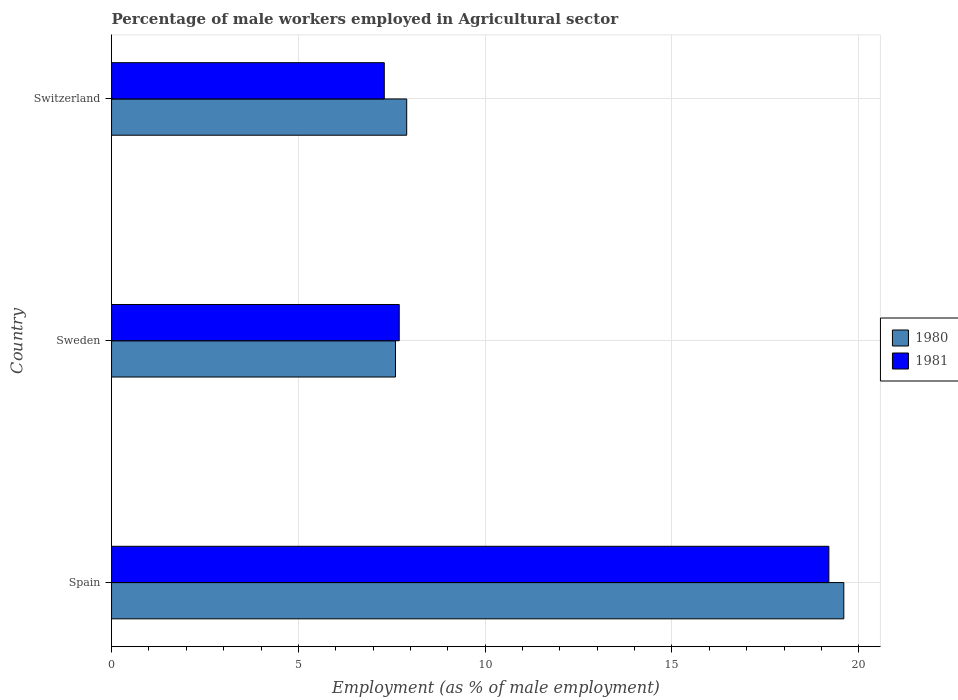How many different coloured bars are there?
Provide a succinct answer. 2. Are the number of bars per tick equal to the number of legend labels?
Your response must be concise. Yes. How many bars are there on the 3rd tick from the top?
Your response must be concise. 2. What is the label of the 3rd group of bars from the top?
Offer a terse response. Spain. What is the percentage of male workers employed in Agricultural sector in 1980 in Spain?
Your answer should be very brief. 19.6. Across all countries, what is the maximum percentage of male workers employed in Agricultural sector in 1980?
Keep it short and to the point. 19.6. Across all countries, what is the minimum percentage of male workers employed in Agricultural sector in 1981?
Keep it short and to the point. 7.3. In which country was the percentage of male workers employed in Agricultural sector in 1981 maximum?
Provide a succinct answer. Spain. In which country was the percentage of male workers employed in Agricultural sector in 1981 minimum?
Keep it short and to the point. Switzerland. What is the total percentage of male workers employed in Agricultural sector in 1981 in the graph?
Offer a very short reply. 34.2. What is the difference between the percentage of male workers employed in Agricultural sector in 1981 in Spain and that in Sweden?
Keep it short and to the point. 11.5. What is the difference between the percentage of male workers employed in Agricultural sector in 1980 in Spain and the percentage of male workers employed in Agricultural sector in 1981 in Sweden?
Keep it short and to the point. 11.9. What is the average percentage of male workers employed in Agricultural sector in 1981 per country?
Offer a very short reply. 11.4. What is the difference between the percentage of male workers employed in Agricultural sector in 1981 and percentage of male workers employed in Agricultural sector in 1980 in Switzerland?
Your response must be concise. -0.6. What is the ratio of the percentage of male workers employed in Agricultural sector in 1980 in Sweden to that in Switzerland?
Offer a very short reply. 0.96. Is the difference between the percentage of male workers employed in Agricultural sector in 1981 in Spain and Sweden greater than the difference between the percentage of male workers employed in Agricultural sector in 1980 in Spain and Sweden?
Make the answer very short. No. What is the difference between the highest and the second highest percentage of male workers employed in Agricultural sector in 1980?
Ensure brevity in your answer.  11.7. What is the difference between the highest and the lowest percentage of male workers employed in Agricultural sector in 1981?
Offer a very short reply. 11.9. In how many countries, is the percentage of male workers employed in Agricultural sector in 1981 greater than the average percentage of male workers employed in Agricultural sector in 1981 taken over all countries?
Give a very brief answer. 1. What does the 2nd bar from the bottom in Sweden represents?
Your answer should be compact. 1981. How many bars are there?
Give a very brief answer. 6. Are all the bars in the graph horizontal?
Your response must be concise. Yes. How many countries are there in the graph?
Your response must be concise. 3. Does the graph contain any zero values?
Ensure brevity in your answer.  No. Does the graph contain grids?
Your answer should be compact. Yes. Where does the legend appear in the graph?
Ensure brevity in your answer.  Center right. How many legend labels are there?
Your answer should be very brief. 2. What is the title of the graph?
Your response must be concise. Percentage of male workers employed in Agricultural sector. Does "2008" appear as one of the legend labels in the graph?
Give a very brief answer. No. What is the label or title of the X-axis?
Offer a terse response. Employment (as % of male employment). What is the label or title of the Y-axis?
Your answer should be compact. Country. What is the Employment (as % of male employment) of 1980 in Spain?
Provide a succinct answer. 19.6. What is the Employment (as % of male employment) of 1981 in Spain?
Provide a succinct answer. 19.2. What is the Employment (as % of male employment) of 1980 in Sweden?
Offer a terse response. 7.6. What is the Employment (as % of male employment) of 1981 in Sweden?
Provide a succinct answer. 7.7. What is the Employment (as % of male employment) of 1980 in Switzerland?
Offer a terse response. 7.9. What is the Employment (as % of male employment) in 1981 in Switzerland?
Provide a succinct answer. 7.3. Across all countries, what is the maximum Employment (as % of male employment) of 1980?
Your answer should be compact. 19.6. Across all countries, what is the maximum Employment (as % of male employment) of 1981?
Provide a short and direct response. 19.2. Across all countries, what is the minimum Employment (as % of male employment) in 1980?
Ensure brevity in your answer.  7.6. Across all countries, what is the minimum Employment (as % of male employment) of 1981?
Offer a terse response. 7.3. What is the total Employment (as % of male employment) in 1980 in the graph?
Make the answer very short. 35.1. What is the total Employment (as % of male employment) of 1981 in the graph?
Offer a terse response. 34.2. What is the difference between the Employment (as % of male employment) in 1981 in Spain and that in Sweden?
Offer a very short reply. 11.5. What is the difference between the Employment (as % of male employment) in 1981 in Sweden and that in Switzerland?
Make the answer very short. 0.4. What is the difference between the Employment (as % of male employment) in 1980 in Spain and the Employment (as % of male employment) in 1981 in Sweden?
Make the answer very short. 11.9. What is the difference between the Employment (as % of male employment) of 1980 in Spain and the Employment (as % of male employment) of 1981 in Switzerland?
Your response must be concise. 12.3. What is the difference between the Employment (as % of male employment) of 1980 in Sweden and the Employment (as % of male employment) of 1981 in Switzerland?
Offer a very short reply. 0.3. What is the average Employment (as % of male employment) in 1981 per country?
Make the answer very short. 11.4. What is the difference between the Employment (as % of male employment) in 1980 and Employment (as % of male employment) in 1981 in Spain?
Provide a succinct answer. 0.4. What is the difference between the Employment (as % of male employment) of 1980 and Employment (as % of male employment) of 1981 in Sweden?
Give a very brief answer. -0.1. What is the difference between the Employment (as % of male employment) of 1980 and Employment (as % of male employment) of 1981 in Switzerland?
Keep it short and to the point. 0.6. What is the ratio of the Employment (as % of male employment) in 1980 in Spain to that in Sweden?
Your response must be concise. 2.58. What is the ratio of the Employment (as % of male employment) of 1981 in Spain to that in Sweden?
Offer a terse response. 2.49. What is the ratio of the Employment (as % of male employment) in 1980 in Spain to that in Switzerland?
Offer a terse response. 2.48. What is the ratio of the Employment (as % of male employment) in 1981 in Spain to that in Switzerland?
Your response must be concise. 2.63. What is the ratio of the Employment (as % of male employment) of 1980 in Sweden to that in Switzerland?
Offer a terse response. 0.96. What is the ratio of the Employment (as % of male employment) in 1981 in Sweden to that in Switzerland?
Keep it short and to the point. 1.05. What is the difference between the highest and the second highest Employment (as % of male employment) in 1981?
Ensure brevity in your answer.  11.5. 